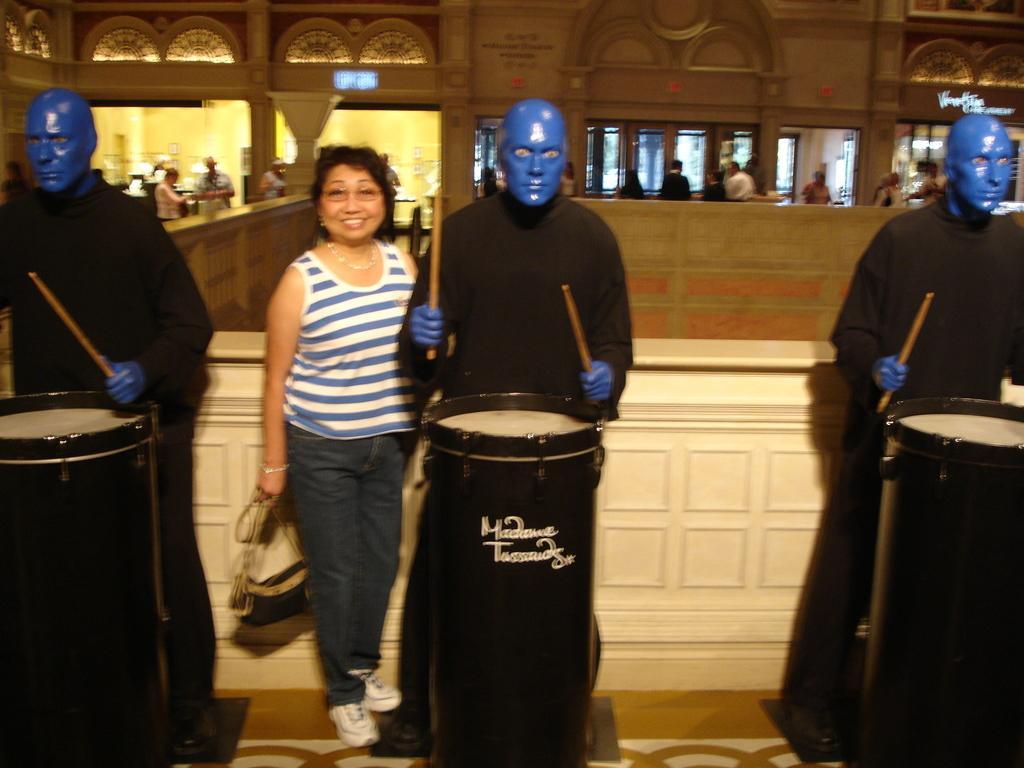How would you summarize this image in a sentence or two? In this image, I can see the woman standing and smiling. She is holding a bag in her hand. I think these are the statues, which are blue in color. These statues are holding the sticks. I think these are the kind of drums. In the background, I can see few people standing. I think this picture was taken inside the building. This looks like a name board, which is attached to the wall. 